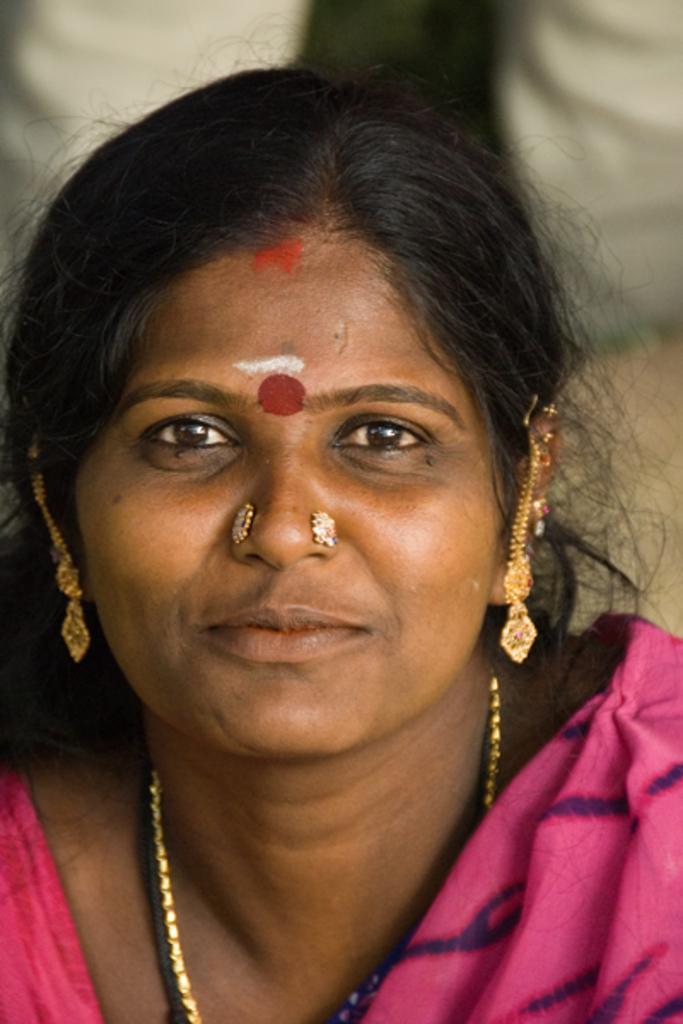How would you summarize this image in a sentence or two? In this image in the foreground there is one woman who is wearing some ornaments, and there is a blurry background. 